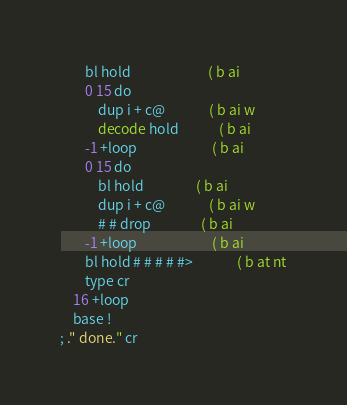Convert code to text. <code><loc_0><loc_0><loc_500><loc_500><_Forth_>		bl hold                         ( b ai
		0 15 do
			dup i + c@              ( b ai w
			decode hold             ( b ai
		-1 +loop                        ( b ai
		0 15 do
			bl hold                 ( b ai
			dup i + c@              ( b ai w
			# # drop                ( b ai
		-1 +loop                        ( b ai
		bl hold # # # # #>              ( b at nt
		type cr
	16 +loop
	base !
; ." done." cr
</code> 